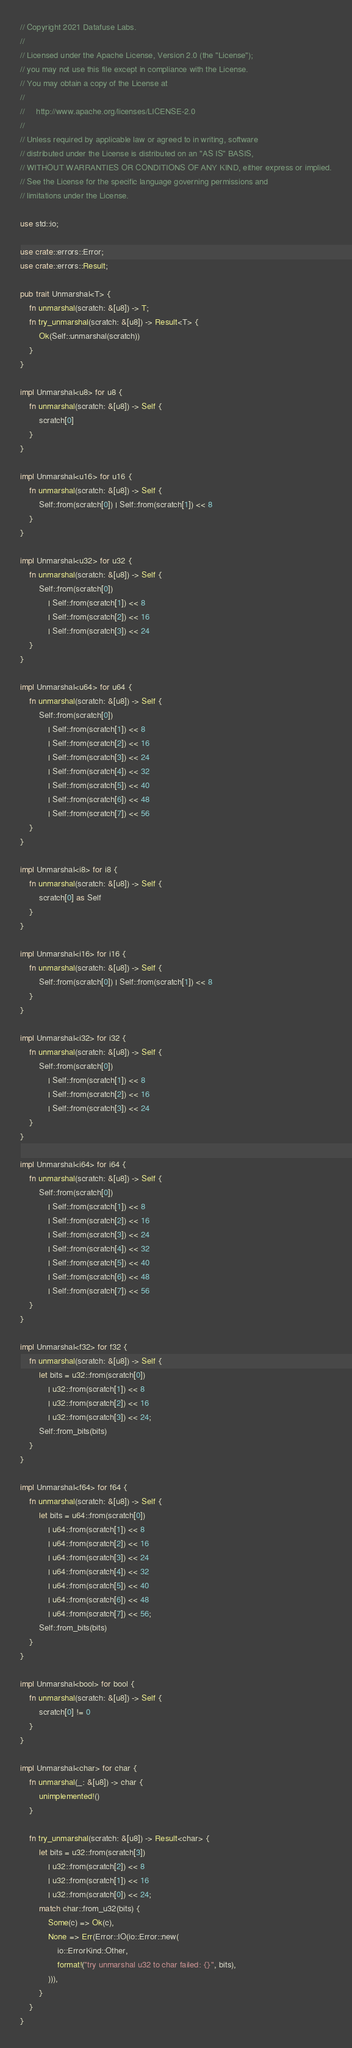Convert code to text. <code><loc_0><loc_0><loc_500><loc_500><_Rust_>// Copyright 2021 Datafuse Labs.
//
// Licensed under the Apache License, Version 2.0 (the "License");
// you may not use this file except in compliance with the License.
// You may obtain a copy of the License at
//
//     http://www.apache.org/licenses/LICENSE-2.0
//
// Unless required by applicable law or agreed to in writing, software
// distributed under the License is distributed on an "AS IS" BASIS,
// WITHOUT WARRANTIES OR CONDITIONS OF ANY KIND, either express or implied.
// See the License for the specific language governing permissions and
// limitations under the License.

use std::io;

use crate::errors::Error;
use crate::errors::Result;

pub trait Unmarshal<T> {
    fn unmarshal(scratch: &[u8]) -> T;
    fn try_unmarshal(scratch: &[u8]) -> Result<T> {
        Ok(Self::unmarshal(scratch))
    }
}

impl Unmarshal<u8> for u8 {
    fn unmarshal(scratch: &[u8]) -> Self {
        scratch[0]
    }
}

impl Unmarshal<u16> for u16 {
    fn unmarshal(scratch: &[u8]) -> Self {
        Self::from(scratch[0]) | Self::from(scratch[1]) << 8
    }
}

impl Unmarshal<u32> for u32 {
    fn unmarshal(scratch: &[u8]) -> Self {
        Self::from(scratch[0])
            | Self::from(scratch[1]) << 8
            | Self::from(scratch[2]) << 16
            | Self::from(scratch[3]) << 24
    }
}

impl Unmarshal<u64> for u64 {
    fn unmarshal(scratch: &[u8]) -> Self {
        Self::from(scratch[0])
            | Self::from(scratch[1]) << 8
            | Self::from(scratch[2]) << 16
            | Self::from(scratch[3]) << 24
            | Self::from(scratch[4]) << 32
            | Self::from(scratch[5]) << 40
            | Self::from(scratch[6]) << 48
            | Self::from(scratch[7]) << 56
    }
}

impl Unmarshal<i8> for i8 {
    fn unmarshal(scratch: &[u8]) -> Self {
        scratch[0] as Self
    }
}

impl Unmarshal<i16> for i16 {
    fn unmarshal(scratch: &[u8]) -> Self {
        Self::from(scratch[0]) | Self::from(scratch[1]) << 8
    }
}

impl Unmarshal<i32> for i32 {
    fn unmarshal(scratch: &[u8]) -> Self {
        Self::from(scratch[0])
            | Self::from(scratch[1]) << 8
            | Self::from(scratch[2]) << 16
            | Self::from(scratch[3]) << 24
    }
}

impl Unmarshal<i64> for i64 {
    fn unmarshal(scratch: &[u8]) -> Self {
        Self::from(scratch[0])
            | Self::from(scratch[1]) << 8
            | Self::from(scratch[2]) << 16
            | Self::from(scratch[3]) << 24
            | Self::from(scratch[4]) << 32
            | Self::from(scratch[5]) << 40
            | Self::from(scratch[6]) << 48
            | Self::from(scratch[7]) << 56
    }
}

impl Unmarshal<f32> for f32 {
    fn unmarshal(scratch: &[u8]) -> Self {
        let bits = u32::from(scratch[0])
            | u32::from(scratch[1]) << 8
            | u32::from(scratch[2]) << 16
            | u32::from(scratch[3]) << 24;
        Self::from_bits(bits)
    }
}

impl Unmarshal<f64> for f64 {
    fn unmarshal(scratch: &[u8]) -> Self {
        let bits = u64::from(scratch[0])
            | u64::from(scratch[1]) << 8
            | u64::from(scratch[2]) << 16
            | u64::from(scratch[3]) << 24
            | u64::from(scratch[4]) << 32
            | u64::from(scratch[5]) << 40
            | u64::from(scratch[6]) << 48
            | u64::from(scratch[7]) << 56;
        Self::from_bits(bits)
    }
}

impl Unmarshal<bool> for bool {
    fn unmarshal(scratch: &[u8]) -> Self {
        scratch[0] != 0
    }
}

impl Unmarshal<char> for char {
    fn unmarshal(_: &[u8]) -> char {
        unimplemented!()
    }

    fn try_unmarshal(scratch: &[u8]) -> Result<char> {
        let bits = u32::from(scratch[3])
            | u32::from(scratch[2]) << 8
            | u32::from(scratch[1]) << 16
            | u32::from(scratch[0]) << 24;
        match char::from_u32(bits) {
            Some(c) => Ok(c),
            None => Err(Error::IO(io::Error::new(
                io::ErrorKind::Other,
                format!("try unmarshal u32 to char failed: {}", bits),
            ))),
        }
    }
}
</code> 